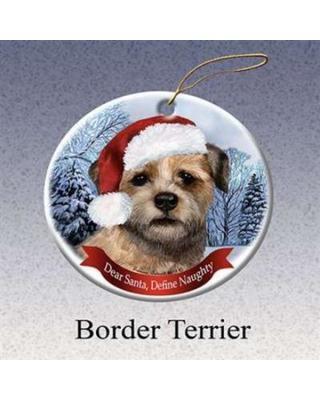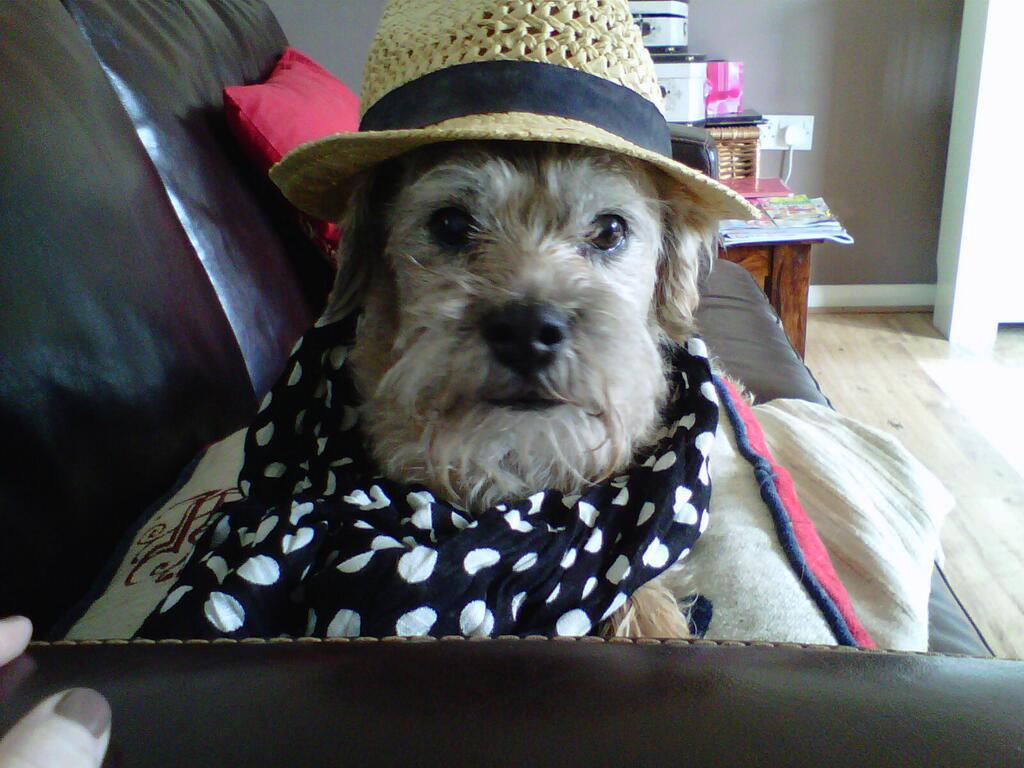The first image is the image on the left, the second image is the image on the right. For the images shown, is this caption "The dog in the image on the right is wearing a hat with a black band around the crown." true? Answer yes or no. Yes. The first image is the image on the left, the second image is the image on the right. Examine the images to the left and right. Is the description "the dog has a hat with a brim in the right side pic" accurate? Answer yes or no. Yes. 